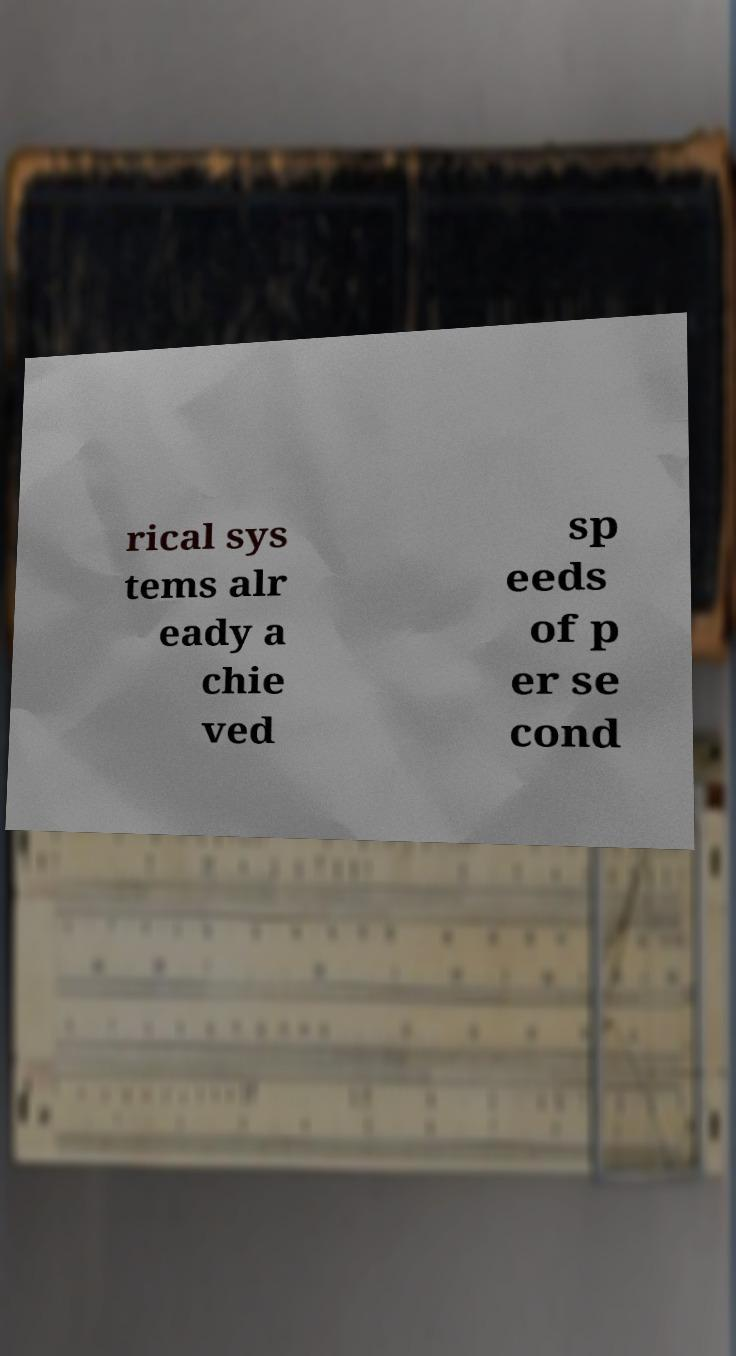What messages or text are displayed in this image? I need them in a readable, typed format. rical sys tems alr eady a chie ved sp eeds of p er se cond 